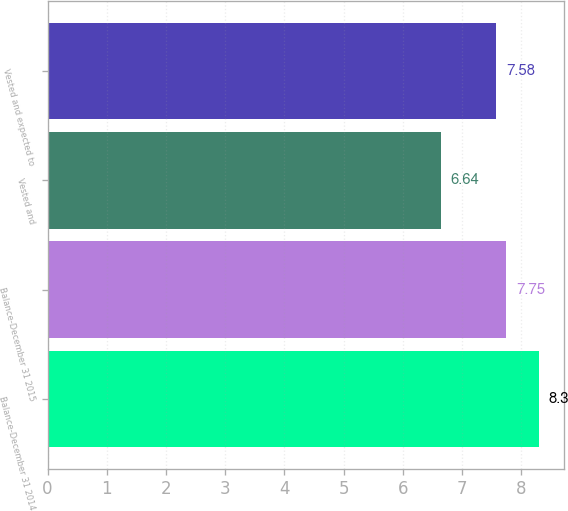Convert chart. <chart><loc_0><loc_0><loc_500><loc_500><bar_chart><fcel>Balance-December 31 2014<fcel>Balance-December 31 2015<fcel>Vested and<fcel>Vested and expected to<nl><fcel>8.3<fcel>7.75<fcel>6.64<fcel>7.58<nl></chart> 